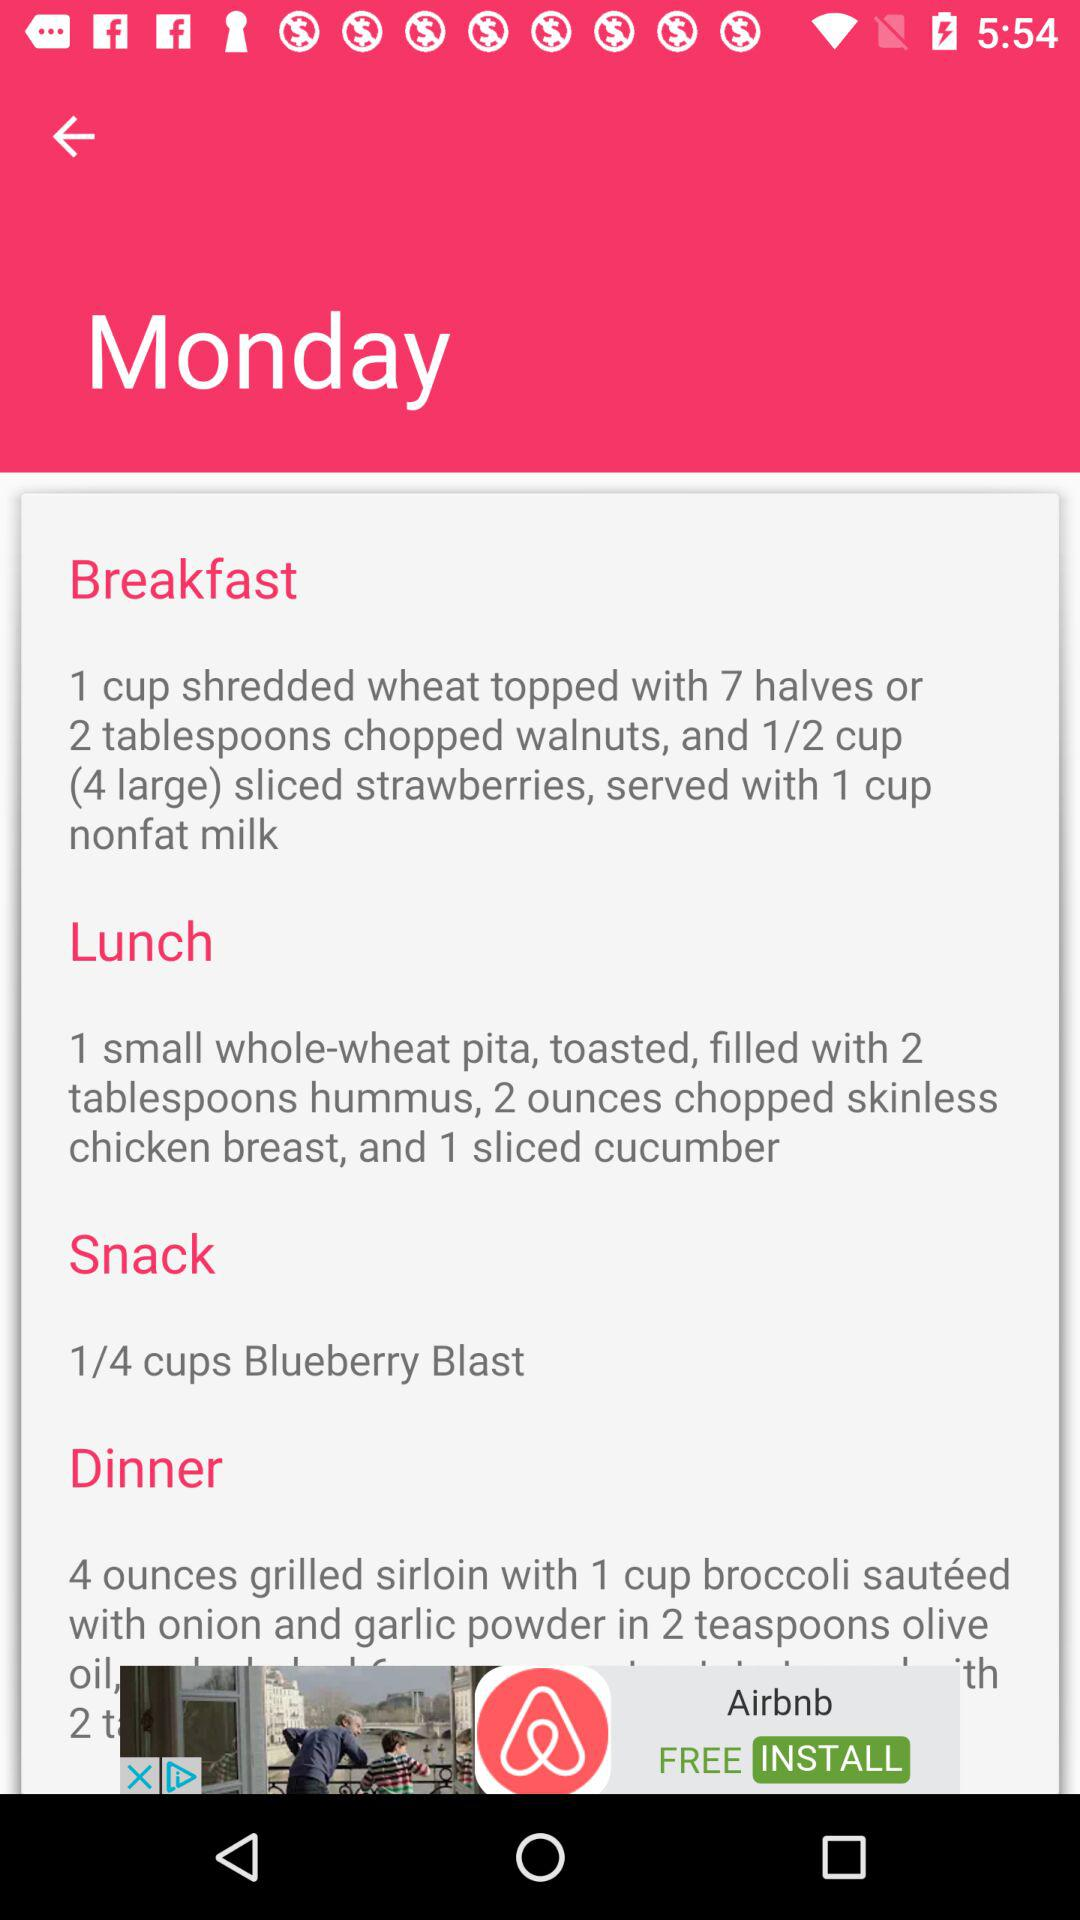What day has been mentioned? The mentioned day is Monday. 